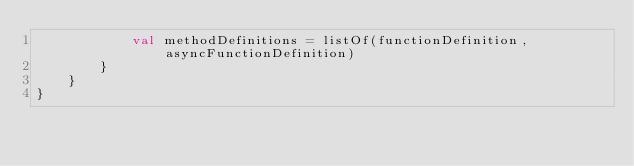Convert code to text. <code><loc_0><loc_0><loc_500><loc_500><_Kotlin_>            val methodDefinitions = listOf(functionDefinition, asyncFunctionDefinition)
        }
    }
}
</code> 